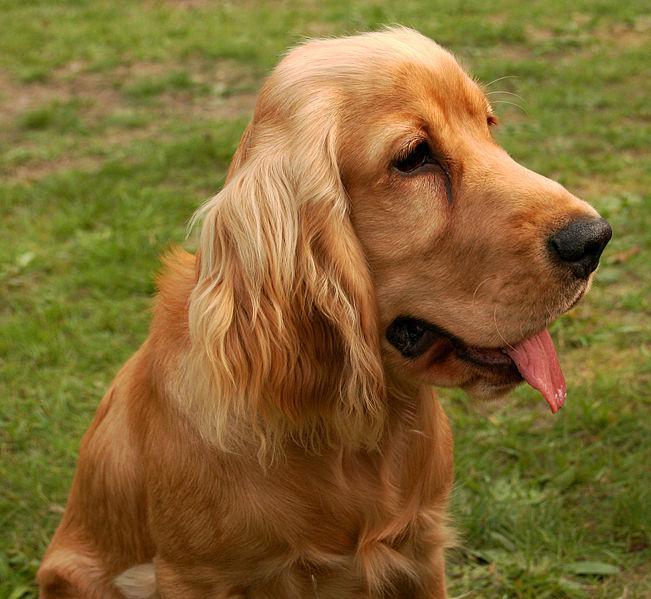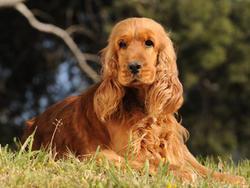The first image is the image on the left, the second image is the image on the right. Evaluate the accuracy of this statement regarding the images: "The dogs in the image on the right are not on grass.". Is it true? Answer yes or no. No. 